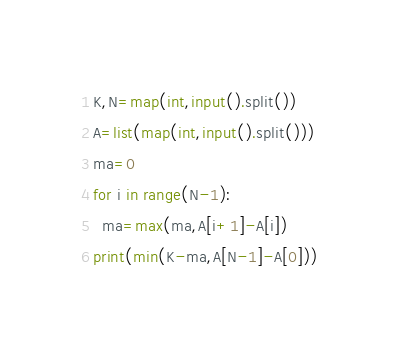<code> <loc_0><loc_0><loc_500><loc_500><_Python_>K,N=map(int,input().split())
A=list(map(int,input().split()))
ma=0
for i in range(N-1):
  ma=max(ma,A[i+1]-A[i])
print(min(K-ma,A[N-1]-A[0]))
</code> 